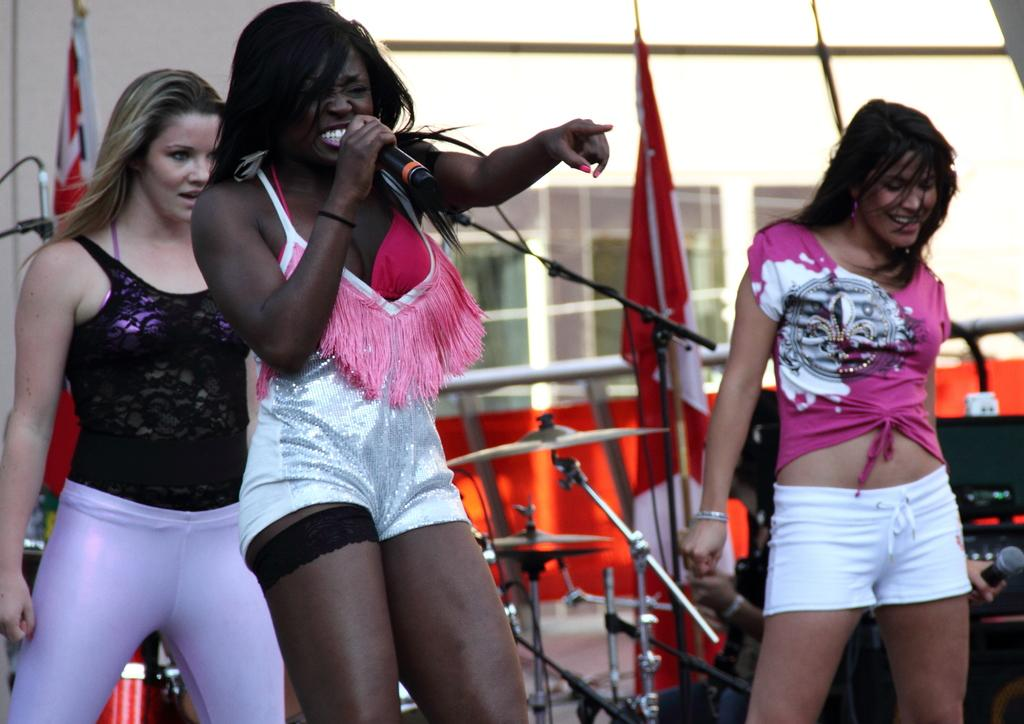How many women are in the image? There are women in the image, but the exact number is not specified. What is one of the women doing in the image? One woman is holding a microphone in the image. What can be seen in the background of the image? There is a building and a flag in the background of the image. What else is present in the background of the image? Musical instruments are present in the background of the image. Can you tell me what type of milk is being served at the zoo in the image? There is no mention of milk or a zoo in the image, so it is not possible to answer that question. 